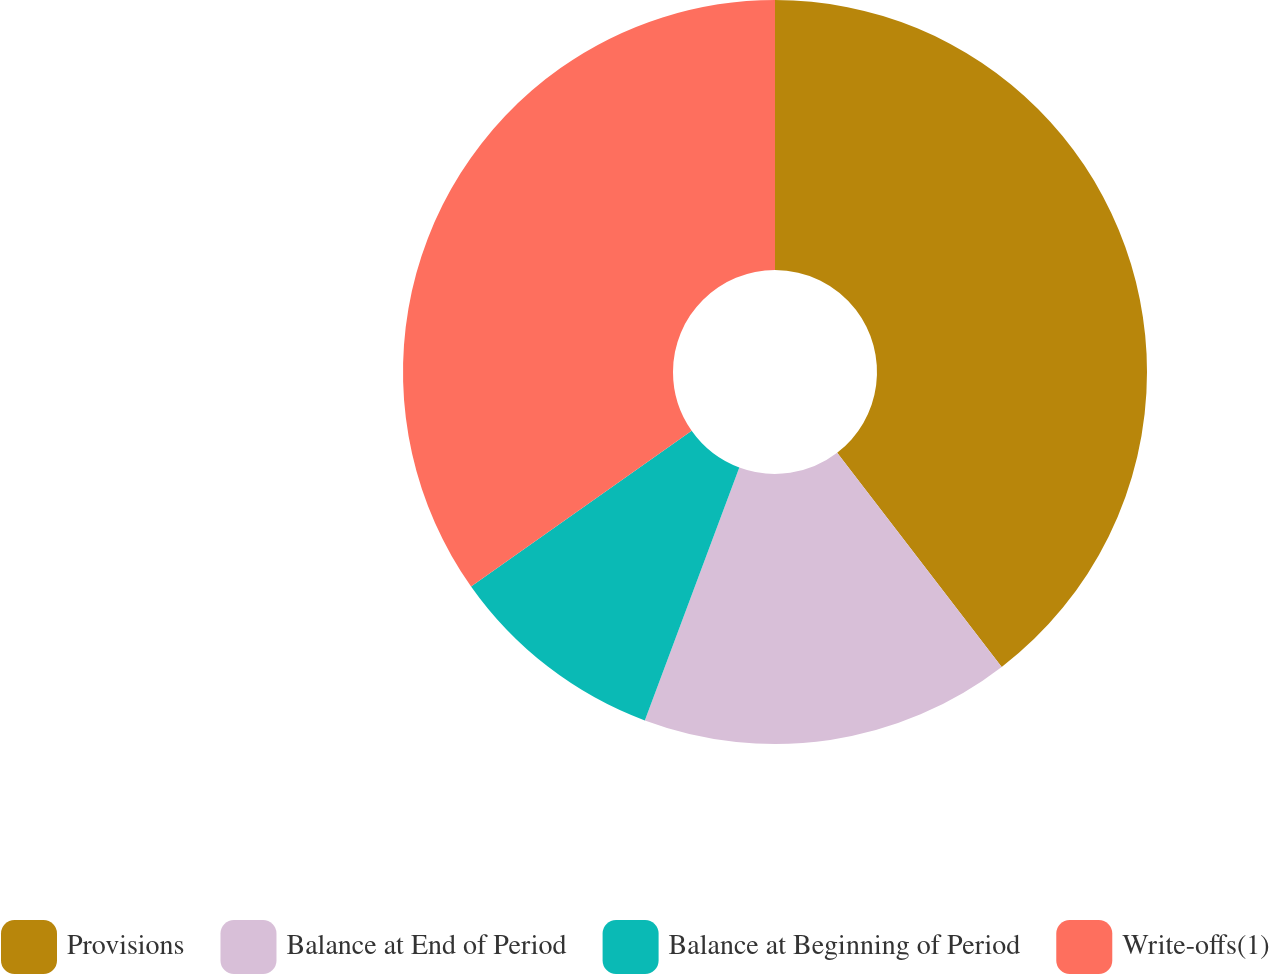<chart> <loc_0><loc_0><loc_500><loc_500><pie_chart><fcel>Provisions<fcel>Balance at End of Period<fcel>Balance at Beginning of Period<fcel>Write-offs(1)<nl><fcel>39.57%<fcel>16.12%<fcel>9.53%<fcel>34.78%<nl></chart> 